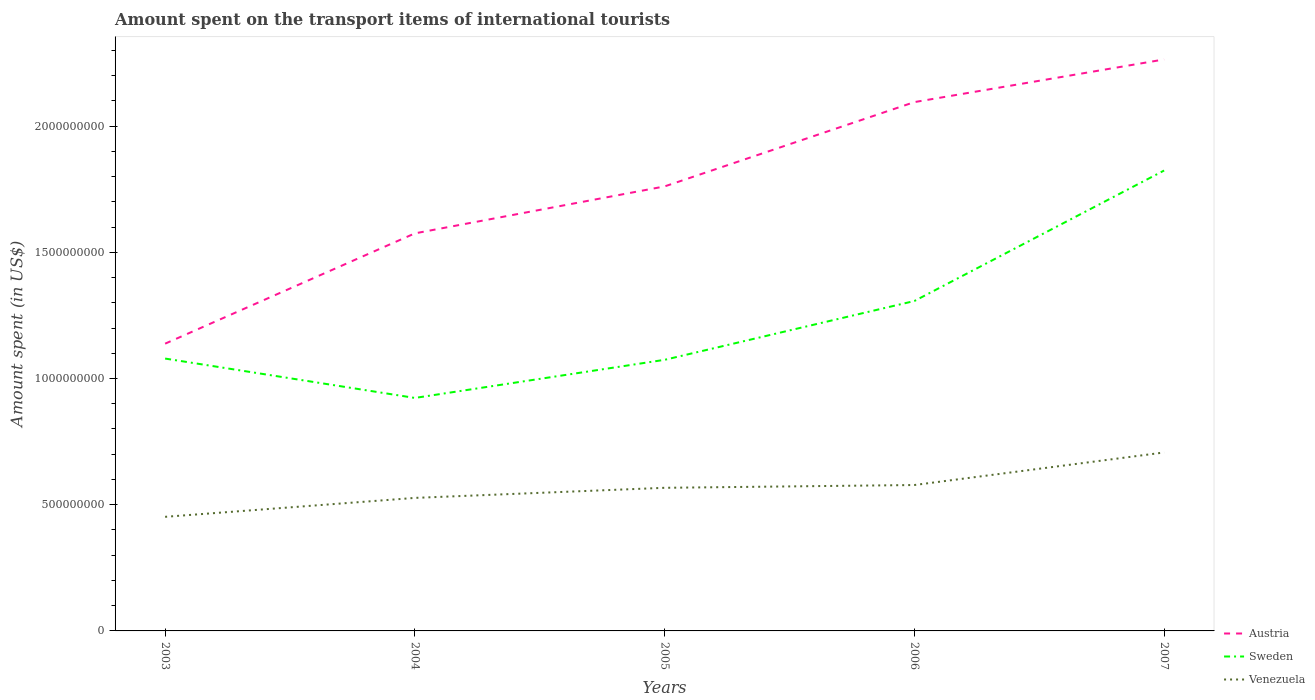How many different coloured lines are there?
Your answer should be compact. 3. Does the line corresponding to Venezuela intersect with the line corresponding to Austria?
Your response must be concise. No. Is the number of lines equal to the number of legend labels?
Give a very brief answer. Yes. Across all years, what is the maximum amount spent on the transport items of international tourists in Sweden?
Your answer should be very brief. 9.23e+08. In which year was the amount spent on the transport items of international tourists in Sweden maximum?
Ensure brevity in your answer.  2004. What is the total amount spent on the transport items of international tourists in Austria in the graph?
Your answer should be compact. -4.37e+08. What is the difference between the highest and the second highest amount spent on the transport items of international tourists in Sweden?
Your response must be concise. 9.01e+08. What is the difference between the highest and the lowest amount spent on the transport items of international tourists in Venezuela?
Offer a terse response. 3. Is the amount spent on the transport items of international tourists in Austria strictly greater than the amount spent on the transport items of international tourists in Venezuela over the years?
Your answer should be compact. No. How many lines are there?
Your answer should be compact. 3. How many years are there in the graph?
Give a very brief answer. 5. Where does the legend appear in the graph?
Ensure brevity in your answer.  Bottom right. What is the title of the graph?
Ensure brevity in your answer.  Amount spent on the transport items of international tourists. Does "Liberia" appear as one of the legend labels in the graph?
Offer a terse response. No. What is the label or title of the Y-axis?
Provide a succinct answer. Amount spent (in US$). What is the Amount spent (in US$) in Austria in 2003?
Give a very brief answer. 1.14e+09. What is the Amount spent (in US$) in Sweden in 2003?
Provide a succinct answer. 1.08e+09. What is the Amount spent (in US$) of Venezuela in 2003?
Give a very brief answer. 4.52e+08. What is the Amount spent (in US$) of Austria in 2004?
Keep it short and to the point. 1.58e+09. What is the Amount spent (in US$) in Sweden in 2004?
Make the answer very short. 9.23e+08. What is the Amount spent (in US$) in Venezuela in 2004?
Offer a terse response. 5.27e+08. What is the Amount spent (in US$) in Austria in 2005?
Make the answer very short. 1.76e+09. What is the Amount spent (in US$) in Sweden in 2005?
Provide a short and direct response. 1.07e+09. What is the Amount spent (in US$) of Venezuela in 2005?
Offer a terse response. 5.67e+08. What is the Amount spent (in US$) of Austria in 2006?
Your answer should be very brief. 2.10e+09. What is the Amount spent (in US$) in Sweden in 2006?
Provide a succinct answer. 1.31e+09. What is the Amount spent (in US$) in Venezuela in 2006?
Provide a succinct answer. 5.78e+08. What is the Amount spent (in US$) of Austria in 2007?
Offer a very short reply. 2.26e+09. What is the Amount spent (in US$) of Sweden in 2007?
Keep it short and to the point. 1.82e+09. What is the Amount spent (in US$) of Venezuela in 2007?
Offer a terse response. 7.07e+08. Across all years, what is the maximum Amount spent (in US$) of Austria?
Offer a terse response. 2.26e+09. Across all years, what is the maximum Amount spent (in US$) in Sweden?
Give a very brief answer. 1.82e+09. Across all years, what is the maximum Amount spent (in US$) in Venezuela?
Make the answer very short. 7.07e+08. Across all years, what is the minimum Amount spent (in US$) in Austria?
Your response must be concise. 1.14e+09. Across all years, what is the minimum Amount spent (in US$) of Sweden?
Offer a very short reply. 9.23e+08. Across all years, what is the minimum Amount spent (in US$) in Venezuela?
Your answer should be very brief. 4.52e+08. What is the total Amount spent (in US$) in Austria in the graph?
Make the answer very short. 8.83e+09. What is the total Amount spent (in US$) of Sweden in the graph?
Provide a succinct answer. 6.21e+09. What is the total Amount spent (in US$) in Venezuela in the graph?
Give a very brief answer. 2.83e+09. What is the difference between the Amount spent (in US$) of Austria in 2003 and that in 2004?
Give a very brief answer. -4.37e+08. What is the difference between the Amount spent (in US$) of Sweden in 2003 and that in 2004?
Your answer should be compact. 1.56e+08. What is the difference between the Amount spent (in US$) of Venezuela in 2003 and that in 2004?
Provide a short and direct response. -7.50e+07. What is the difference between the Amount spent (in US$) of Austria in 2003 and that in 2005?
Offer a very short reply. -6.23e+08. What is the difference between the Amount spent (in US$) of Venezuela in 2003 and that in 2005?
Keep it short and to the point. -1.15e+08. What is the difference between the Amount spent (in US$) in Austria in 2003 and that in 2006?
Keep it short and to the point. -9.57e+08. What is the difference between the Amount spent (in US$) in Sweden in 2003 and that in 2006?
Make the answer very short. -2.28e+08. What is the difference between the Amount spent (in US$) of Venezuela in 2003 and that in 2006?
Keep it short and to the point. -1.26e+08. What is the difference between the Amount spent (in US$) in Austria in 2003 and that in 2007?
Give a very brief answer. -1.13e+09. What is the difference between the Amount spent (in US$) of Sweden in 2003 and that in 2007?
Your response must be concise. -7.45e+08. What is the difference between the Amount spent (in US$) of Venezuela in 2003 and that in 2007?
Your answer should be very brief. -2.55e+08. What is the difference between the Amount spent (in US$) of Austria in 2004 and that in 2005?
Give a very brief answer. -1.86e+08. What is the difference between the Amount spent (in US$) in Sweden in 2004 and that in 2005?
Provide a short and direct response. -1.51e+08. What is the difference between the Amount spent (in US$) in Venezuela in 2004 and that in 2005?
Your answer should be compact. -4.00e+07. What is the difference between the Amount spent (in US$) of Austria in 2004 and that in 2006?
Provide a succinct answer. -5.20e+08. What is the difference between the Amount spent (in US$) in Sweden in 2004 and that in 2006?
Your answer should be compact. -3.84e+08. What is the difference between the Amount spent (in US$) in Venezuela in 2004 and that in 2006?
Your answer should be compact. -5.10e+07. What is the difference between the Amount spent (in US$) in Austria in 2004 and that in 2007?
Offer a terse response. -6.89e+08. What is the difference between the Amount spent (in US$) of Sweden in 2004 and that in 2007?
Your response must be concise. -9.01e+08. What is the difference between the Amount spent (in US$) in Venezuela in 2004 and that in 2007?
Keep it short and to the point. -1.80e+08. What is the difference between the Amount spent (in US$) of Austria in 2005 and that in 2006?
Your answer should be very brief. -3.34e+08. What is the difference between the Amount spent (in US$) of Sweden in 2005 and that in 2006?
Keep it short and to the point. -2.33e+08. What is the difference between the Amount spent (in US$) in Venezuela in 2005 and that in 2006?
Ensure brevity in your answer.  -1.10e+07. What is the difference between the Amount spent (in US$) of Austria in 2005 and that in 2007?
Offer a terse response. -5.03e+08. What is the difference between the Amount spent (in US$) in Sweden in 2005 and that in 2007?
Offer a very short reply. -7.50e+08. What is the difference between the Amount spent (in US$) in Venezuela in 2005 and that in 2007?
Keep it short and to the point. -1.40e+08. What is the difference between the Amount spent (in US$) in Austria in 2006 and that in 2007?
Your response must be concise. -1.69e+08. What is the difference between the Amount spent (in US$) of Sweden in 2006 and that in 2007?
Provide a succinct answer. -5.17e+08. What is the difference between the Amount spent (in US$) in Venezuela in 2006 and that in 2007?
Offer a very short reply. -1.29e+08. What is the difference between the Amount spent (in US$) of Austria in 2003 and the Amount spent (in US$) of Sweden in 2004?
Your answer should be compact. 2.15e+08. What is the difference between the Amount spent (in US$) of Austria in 2003 and the Amount spent (in US$) of Venezuela in 2004?
Provide a succinct answer. 6.11e+08. What is the difference between the Amount spent (in US$) in Sweden in 2003 and the Amount spent (in US$) in Venezuela in 2004?
Make the answer very short. 5.52e+08. What is the difference between the Amount spent (in US$) of Austria in 2003 and the Amount spent (in US$) of Sweden in 2005?
Keep it short and to the point. 6.40e+07. What is the difference between the Amount spent (in US$) in Austria in 2003 and the Amount spent (in US$) in Venezuela in 2005?
Provide a short and direct response. 5.71e+08. What is the difference between the Amount spent (in US$) in Sweden in 2003 and the Amount spent (in US$) in Venezuela in 2005?
Keep it short and to the point. 5.12e+08. What is the difference between the Amount spent (in US$) of Austria in 2003 and the Amount spent (in US$) of Sweden in 2006?
Your response must be concise. -1.69e+08. What is the difference between the Amount spent (in US$) of Austria in 2003 and the Amount spent (in US$) of Venezuela in 2006?
Offer a very short reply. 5.60e+08. What is the difference between the Amount spent (in US$) in Sweden in 2003 and the Amount spent (in US$) in Venezuela in 2006?
Ensure brevity in your answer.  5.01e+08. What is the difference between the Amount spent (in US$) of Austria in 2003 and the Amount spent (in US$) of Sweden in 2007?
Ensure brevity in your answer.  -6.86e+08. What is the difference between the Amount spent (in US$) of Austria in 2003 and the Amount spent (in US$) of Venezuela in 2007?
Offer a very short reply. 4.31e+08. What is the difference between the Amount spent (in US$) in Sweden in 2003 and the Amount spent (in US$) in Venezuela in 2007?
Provide a short and direct response. 3.72e+08. What is the difference between the Amount spent (in US$) in Austria in 2004 and the Amount spent (in US$) in Sweden in 2005?
Offer a terse response. 5.01e+08. What is the difference between the Amount spent (in US$) of Austria in 2004 and the Amount spent (in US$) of Venezuela in 2005?
Give a very brief answer. 1.01e+09. What is the difference between the Amount spent (in US$) of Sweden in 2004 and the Amount spent (in US$) of Venezuela in 2005?
Ensure brevity in your answer.  3.56e+08. What is the difference between the Amount spent (in US$) in Austria in 2004 and the Amount spent (in US$) in Sweden in 2006?
Give a very brief answer. 2.68e+08. What is the difference between the Amount spent (in US$) of Austria in 2004 and the Amount spent (in US$) of Venezuela in 2006?
Ensure brevity in your answer.  9.97e+08. What is the difference between the Amount spent (in US$) of Sweden in 2004 and the Amount spent (in US$) of Venezuela in 2006?
Your answer should be very brief. 3.45e+08. What is the difference between the Amount spent (in US$) of Austria in 2004 and the Amount spent (in US$) of Sweden in 2007?
Ensure brevity in your answer.  -2.49e+08. What is the difference between the Amount spent (in US$) in Austria in 2004 and the Amount spent (in US$) in Venezuela in 2007?
Ensure brevity in your answer.  8.68e+08. What is the difference between the Amount spent (in US$) in Sweden in 2004 and the Amount spent (in US$) in Venezuela in 2007?
Offer a very short reply. 2.16e+08. What is the difference between the Amount spent (in US$) in Austria in 2005 and the Amount spent (in US$) in Sweden in 2006?
Offer a very short reply. 4.54e+08. What is the difference between the Amount spent (in US$) of Austria in 2005 and the Amount spent (in US$) of Venezuela in 2006?
Provide a short and direct response. 1.18e+09. What is the difference between the Amount spent (in US$) in Sweden in 2005 and the Amount spent (in US$) in Venezuela in 2006?
Give a very brief answer. 4.96e+08. What is the difference between the Amount spent (in US$) in Austria in 2005 and the Amount spent (in US$) in Sweden in 2007?
Your answer should be very brief. -6.30e+07. What is the difference between the Amount spent (in US$) of Austria in 2005 and the Amount spent (in US$) of Venezuela in 2007?
Provide a short and direct response. 1.05e+09. What is the difference between the Amount spent (in US$) of Sweden in 2005 and the Amount spent (in US$) of Venezuela in 2007?
Your answer should be very brief. 3.67e+08. What is the difference between the Amount spent (in US$) of Austria in 2006 and the Amount spent (in US$) of Sweden in 2007?
Give a very brief answer. 2.71e+08. What is the difference between the Amount spent (in US$) in Austria in 2006 and the Amount spent (in US$) in Venezuela in 2007?
Your answer should be very brief. 1.39e+09. What is the difference between the Amount spent (in US$) of Sweden in 2006 and the Amount spent (in US$) of Venezuela in 2007?
Provide a short and direct response. 6.00e+08. What is the average Amount spent (in US$) in Austria per year?
Offer a very short reply. 1.77e+09. What is the average Amount spent (in US$) in Sweden per year?
Offer a terse response. 1.24e+09. What is the average Amount spent (in US$) in Venezuela per year?
Offer a very short reply. 5.66e+08. In the year 2003, what is the difference between the Amount spent (in US$) in Austria and Amount spent (in US$) in Sweden?
Offer a terse response. 5.90e+07. In the year 2003, what is the difference between the Amount spent (in US$) of Austria and Amount spent (in US$) of Venezuela?
Ensure brevity in your answer.  6.86e+08. In the year 2003, what is the difference between the Amount spent (in US$) in Sweden and Amount spent (in US$) in Venezuela?
Offer a terse response. 6.27e+08. In the year 2004, what is the difference between the Amount spent (in US$) of Austria and Amount spent (in US$) of Sweden?
Your answer should be very brief. 6.52e+08. In the year 2004, what is the difference between the Amount spent (in US$) in Austria and Amount spent (in US$) in Venezuela?
Give a very brief answer. 1.05e+09. In the year 2004, what is the difference between the Amount spent (in US$) of Sweden and Amount spent (in US$) of Venezuela?
Keep it short and to the point. 3.96e+08. In the year 2005, what is the difference between the Amount spent (in US$) in Austria and Amount spent (in US$) in Sweden?
Make the answer very short. 6.87e+08. In the year 2005, what is the difference between the Amount spent (in US$) of Austria and Amount spent (in US$) of Venezuela?
Keep it short and to the point. 1.19e+09. In the year 2005, what is the difference between the Amount spent (in US$) of Sweden and Amount spent (in US$) of Venezuela?
Make the answer very short. 5.07e+08. In the year 2006, what is the difference between the Amount spent (in US$) in Austria and Amount spent (in US$) in Sweden?
Provide a succinct answer. 7.88e+08. In the year 2006, what is the difference between the Amount spent (in US$) of Austria and Amount spent (in US$) of Venezuela?
Your answer should be compact. 1.52e+09. In the year 2006, what is the difference between the Amount spent (in US$) in Sweden and Amount spent (in US$) in Venezuela?
Your answer should be very brief. 7.29e+08. In the year 2007, what is the difference between the Amount spent (in US$) of Austria and Amount spent (in US$) of Sweden?
Keep it short and to the point. 4.40e+08. In the year 2007, what is the difference between the Amount spent (in US$) of Austria and Amount spent (in US$) of Venezuela?
Make the answer very short. 1.56e+09. In the year 2007, what is the difference between the Amount spent (in US$) in Sweden and Amount spent (in US$) in Venezuela?
Offer a terse response. 1.12e+09. What is the ratio of the Amount spent (in US$) in Austria in 2003 to that in 2004?
Your answer should be compact. 0.72. What is the ratio of the Amount spent (in US$) of Sweden in 2003 to that in 2004?
Offer a very short reply. 1.17. What is the ratio of the Amount spent (in US$) of Venezuela in 2003 to that in 2004?
Ensure brevity in your answer.  0.86. What is the ratio of the Amount spent (in US$) of Austria in 2003 to that in 2005?
Your answer should be compact. 0.65. What is the ratio of the Amount spent (in US$) of Venezuela in 2003 to that in 2005?
Your answer should be compact. 0.8. What is the ratio of the Amount spent (in US$) of Austria in 2003 to that in 2006?
Your answer should be very brief. 0.54. What is the ratio of the Amount spent (in US$) in Sweden in 2003 to that in 2006?
Your response must be concise. 0.83. What is the ratio of the Amount spent (in US$) of Venezuela in 2003 to that in 2006?
Offer a very short reply. 0.78. What is the ratio of the Amount spent (in US$) in Austria in 2003 to that in 2007?
Your answer should be very brief. 0.5. What is the ratio of the Amount spent (in US$) in Sweden in 2003 to that in 2007?
Your answer should be compact. 0.59. What is the ratio of the Amount spent (in US$) in Venezuela in 2003 to that in 2007?
Your answer should be very brief. 0.64. What is the ratio of the Amount spent (in US$) in Austria in 2004 to that in 2005?
Provide a short and direct response. 0.89. What is the ratio of the Amount spent (in US$) of Sweden in 2004 to that in 2005?
Make the answer very short. 0.86. What is the ratio of the Amount spent (in US$) of Venezuela in 2004 to that in 2005?
Make the answer very short. 0.93. What is the ratio of the Amount spent (in US$) of Austria in 2004 to that in 2006?
Your answer should be very brief. 0.75. What is the ratio of the Amount spent (in US$) of Sweden in 2004 to that in 2006?
Offer a terse response. 0.71. What is the ratio of the Amount spent (in US$) in Venezuela in 2004 to that in 2006?
Your answer should be compact. 0.91. What is the ratio of the Amount spent (in US$) in Austria in 2004 to that in 2007?
Ensure brevity in your answer.  0.7. What is the ratio of the Amount spent (in US$) in Sweden in 2004 to that in 2007?
Offer a very short reply. 0.51. What is the ratio of the Amount spent (in US$) of Venezuela in 2004 to that in 2007?
Make the answer very short. 0.75. What is the ratio of the Amount spent (in US$) of Austria in 2005 to that in 2006?
Your answer should be very brief. 0.84. What is the ratio of the Amount spent (in US$) in Sweden in 2005 to that in 2006?
Provide a short and direct response. 0.82. What is the ratio of the Amount spent (in US$) of Venezuela in 2005 to that in 2006?
Keep it short and to the point. 0.98. What is the ratio of the Amount spent (in US$) of Sweden in 2005 to that in 2007?
Provide a short and direct response. 0.59. What is the ratio of the Amount spent (in US$) in Venezuela in 2005 to that in 2007?
Offer a terse response. 0.8. What is the ratio of the Amount spent (in US$) of Austria in 2006 to that in 2007?
Offer a very short reply. 0.93. What is the ratio of the Amount spent (in US$) in Sweden in 2006 to that in 2007?
Provide a succinct answer. 0.72. What is the ratio of the Amount spent (in US$) of Venezuela in 2006 to that in 2007?
Offer a terse response. 0.82. What is the difference between the highest and the second highest Amount spent (in US$) in Austria?
Your answer should be compact. 1.69e+08. What is the difference between the highest and the second highest Amount spent (in US$) of Sweden?
Offer a terse response. 5.17e+08. What is the difference between the highest and the second highest Amount spent (in US$) in Venezuela?
Make the answer very short. 1.29e+08. What is the difference between the highest and the lowest Amount spent (in US$) in Austria?
Your answer should be compact. 1.13e+09. What is the difference between the highest and the lowest Amount spent (in US$) of Sweden?
Offer a terse response. 9.01e+08. What is the difference between the highest and the lowest Amount spent (in US$) in Venezuela?
Your answer should be compact. 2.55e+08. 